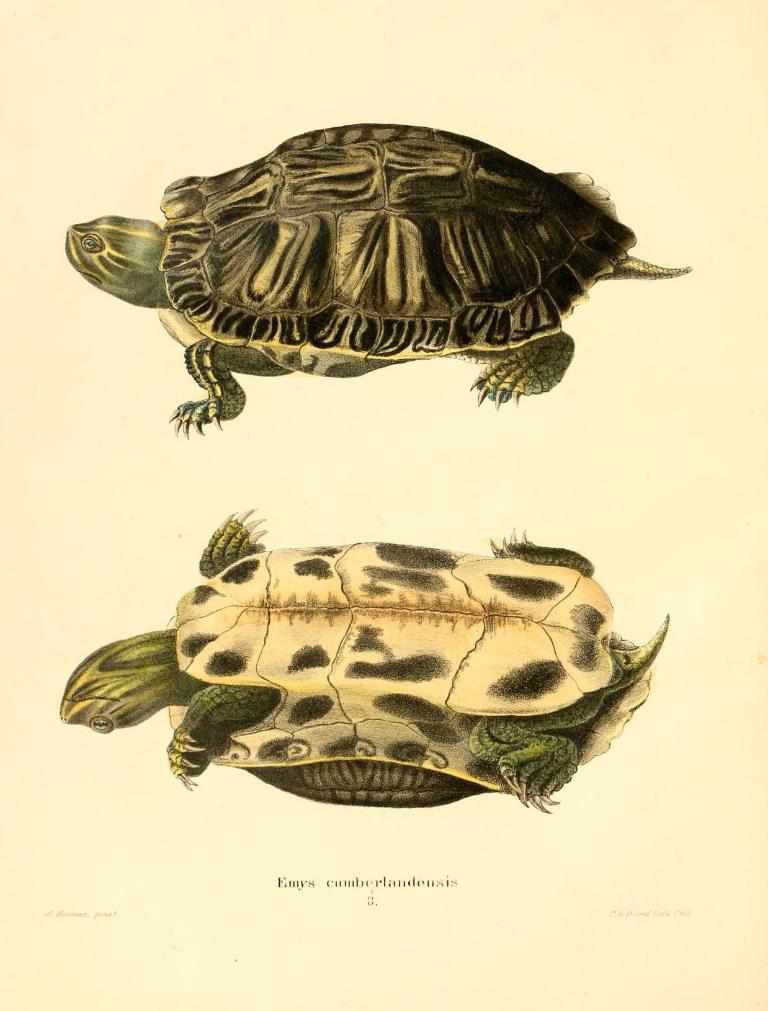How many turtles are present in the image? There are 2 turtles in the picture. What can be found on the bottom side of the picture? There is text written on the bottom side of the picture. How many tomatoes are visible in the picture? There are no tomatoes present in the image; it features 2 turtles and text on the bottom side. Can you tell me how many frogs are hopping around the turtles in the picture? There are no frogs present in the image; it features 2 turtles and text on the bottom side. 